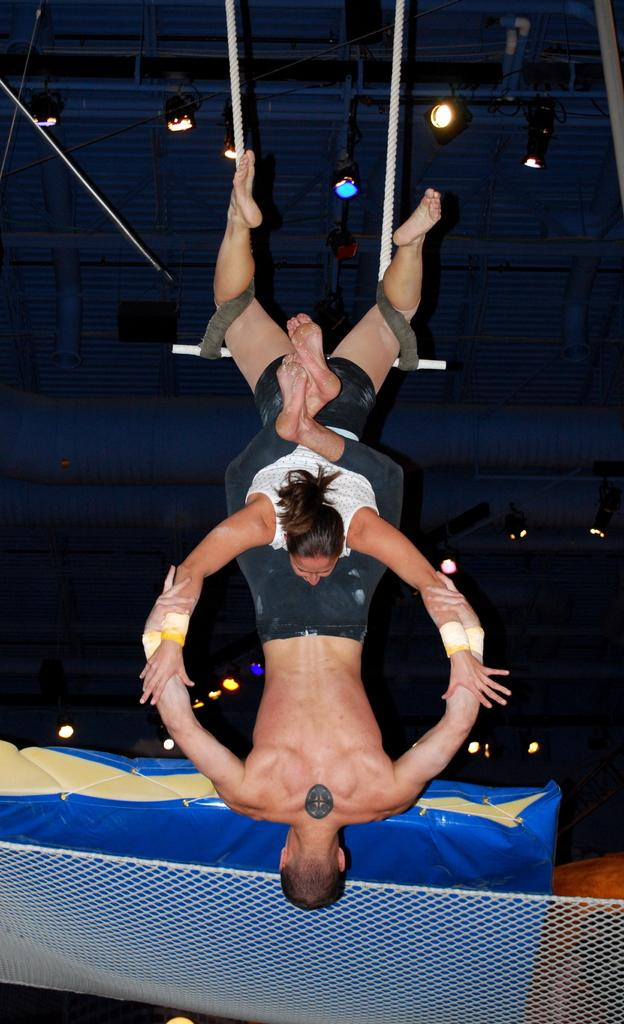What are the two people in the image doing? The two people are hanging on a rope in the image. What is located at the bottom of the image? There is a net at the bottom of the image. What color is the object visible in the image? There is a blue color object in the image. What can be seen on the ceiling in the image? There is a ceiling with lights in the image. What type of bottle can be seen on the prison bed in the image? There is no bottle or prison bed present in the image. 